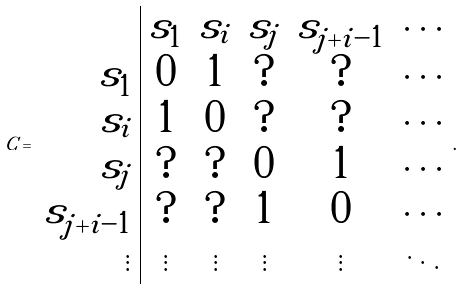Convert formula to latex. <formula><loc_0><loc_0><loc_500><loc_500>C = \begin{array} { r | c c c c c } & s _ { 1 } & s _ { i } & s _ { j } & s _ { j + i - 1 } & \cdots \\ s _ { 1 } & 0 & 1 & ? & ? & \cdots \\ s _ { i } & 1 & 0 & ? & ? & \cdots \\ s _ { j } & ? & ? & 0 & 1 & \cdots \\ s _ { j + i - 1 } & ? & ? & 1 & 0 & \cdots \\ \vdots & \vdots & \vdots & \vdots & \vdots & \ddots \end{array} .</formula> 